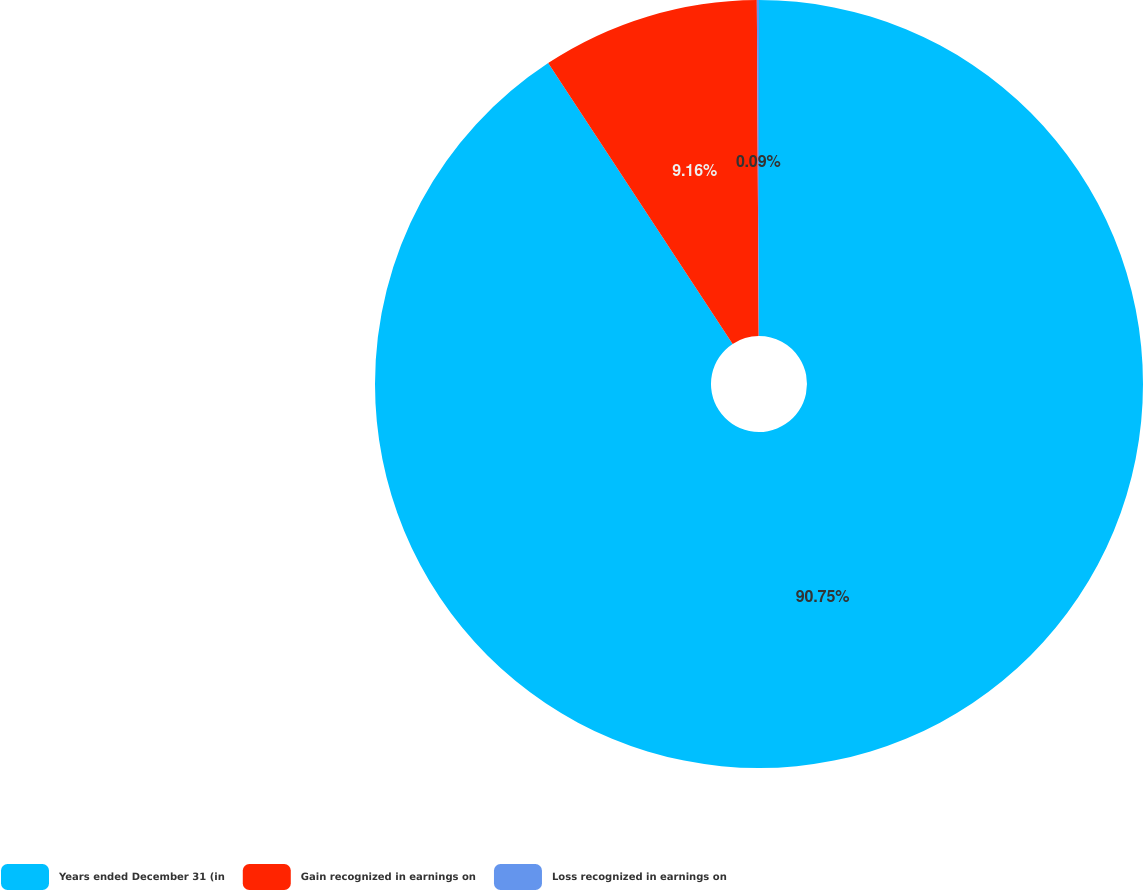Convert chart to OTSL. <chart><loc_0><loc_0><loc_500><loc_500><pie_chart><fcel>Years ended December 31 (in<fcel>Gain recognized in earnings on<fcel>Loss recognized in earnings on<nl><fcel>90.75%<fcel>9.16%<fcel>0.09%<nl></chart> 